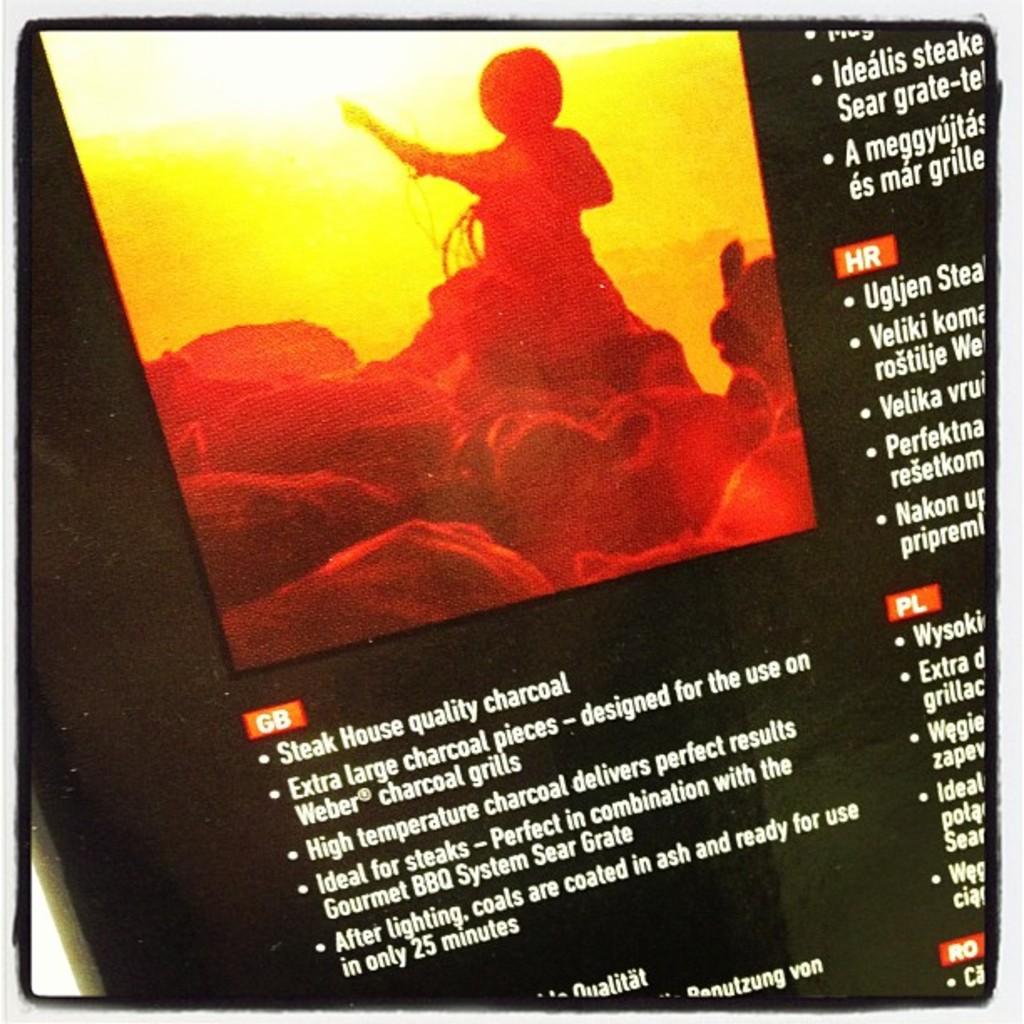What type of quality charcoal is referred to in the first bullet point?
Provide a succinct answer. Steak house. When is the coal ready to use?
Your answer should be compact. After lighting. 